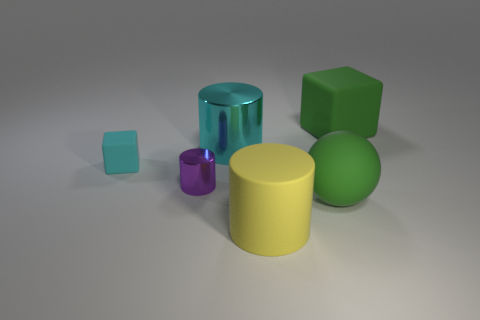Add 2 large objects. How many objects exist? 8 Subtract all balls. How many objects are left? 5 Subtract all cyan metallic cylinders. Subtract all small rubber blocks. How many objects are left? 4 Add 4 small shiny objects. How many small shiny objects are left? 5 Add 1 big matte cylinders. How many big matte cylinders exist? 2 Subtract 0 red blocks. How many objects are left? 6 